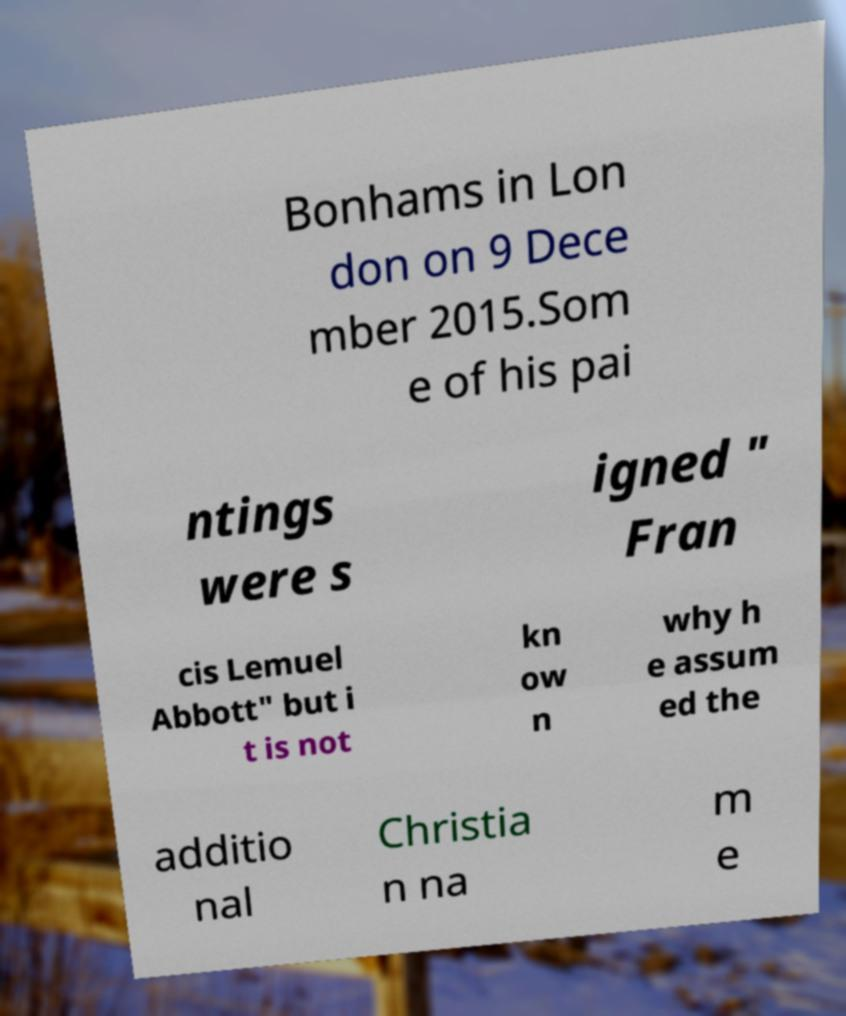Please read and relay the text visible in this image. What does it say? Bonhams in Lon don on 9 Dece mber 2015.Som e of his pai ntings were s igned " Fran cis Lemuel Abbott" but i t is not kn ow n why h e assum ed the additio nal Christia n na m e 